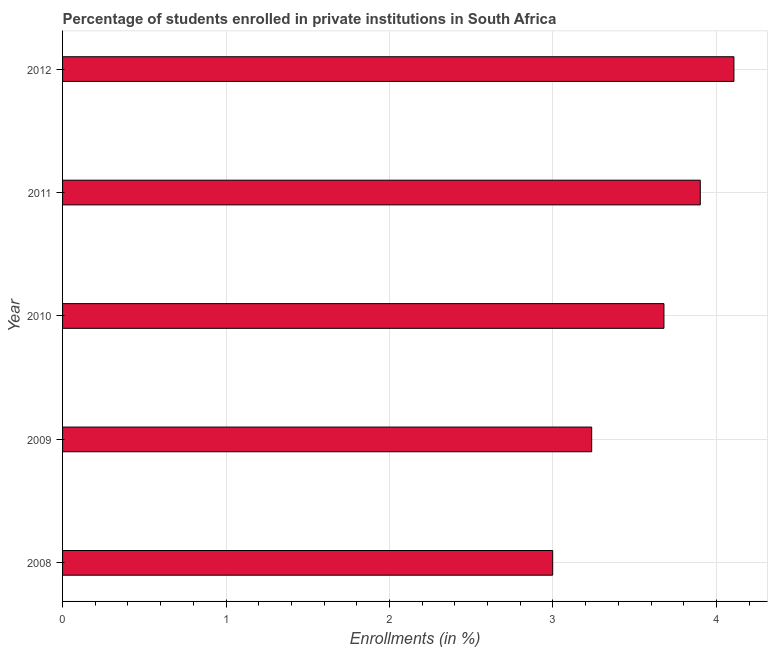Does the graph contain any zero values?
Give a very brief answer. No. Does the graph contain grids?
Your answer should be compact. Yes. What is the title of the graph?
Your response must be concise. Percentage of students enrolled in private institutions in South Africa. What is the label or title of the X-axis?
Make the answer very short. Enrollments (in %). What is the label or title of the Y-axis?
Your answer should be very brief. Year. What is the enrollments in private institutions in 2009?
Offer a very short reply. 3.24. Across all years, what is the maximum enrollments in private institutions?
Offer a very short reply. 4.11. Across all years, what is the minimum enrollments in private institutions?
Provide a succinct answer. 3. What is the sum of the enrollments in private institutions?
Your response must be concise. 17.92. What is the difference between the enrollments in private institutions in 2010 and 2012?
Your response must be concise. -0.43. What is the average enrollments in private institutions per year?
Offer a terse response. 3.58. What is the median enrollments in private institutions?
Your answer should be very brief. 3.68. What is the ratio of the enrollments in private institutions in 2011 to that in 2012?
Ensure brevity in your answer.  0.95. Is the enrollments in private institutions in 2010 less than that in 2011?
Your response must be concise. Yes. Is the difference between the enrollments in private institutions in 2010 and 2012 greater than the difference between any two years?
Ensure brevity in your answer.  No. What is the difference between the highest and the second highest enrollments in private institutions?
Keep it short and to the point. 0.21. Is the sum of the enrollments in private institutions in 2009 and 2010 greater than the maximum enrollments in private institutions across all years?
Offer a very short reply. Yes. What is the difference between the highest and the lowest enrollments in private institutions?
Your answer should be very brief. 1.11. In how many years, is the enrollments in private institutions greater than the average enrollments in private institutions taken over all years?
Offer a very short reply. 3. Are the values on the major ticks of X-axis written in scientific E-notation?
Keep it short and to the point. No. What is the Enrollments (in %) in 2008?
Make the answer very short. 3. What is the Enrollments (in %) of 2009?
Keep it short and to the point. 3.24. What is the Enrollments (in %) in 2010?
Provide a short and direct response. 3.68. What is the Enrollments (in %) in 2011?
Offer a very short reply. 3.9. What is the Enrollments (in %) of 2012?
Offer a terse response. 4.11. What is the difference between the Enrollments (in %) in 2008 and 2009?
Keep it short and to the point. -0.24. What is the difference between the Enrollments (in %) in 2008 and 2010?
Keep it short and to the point. -0.68. What is the difference between the Enrollments (in %) in 2008 and 2011?
Your response must be concise. -0.9. What is the difference between the Enrollments (in %) in 2008 and 2012?
Ensure brevity in your answer.  -1.11. What is the difference between the Enrollments (in %) in 2009 and 2010?
Ensure brevity in your answer.  -0.44. What is the difference between the Enrollments (in %) in 2009 and 2011?
Your answer should be very brief. -0.66. What is the difference between the Enrollments (in %) in 2009 and 2012?
Ensure brevity in your answer.  -0.87. What is the difference between the Enrollments (in %) in 2010 and 2011?
Provide a succinct answer. -0.22. What is the difference between the Enrollments (in %) in 2010 and 2012?
Ensure brevity in your answer.  -0.43. What is the difference between the Enrollments (in %) in 2011 and 2012?
Ensure brevity in your answer.  -0.21. What is the ratio of the Enrollments (in %) in 2008 to that in 2009?
Provide a short and direct response. 0.93. What is the ratio of the Enrollments (in %) in 2008 to that in 2010?
Your answer should be very brief. 0.81. What is the ratio of the Enrollments (in %) in 2008 to that in 2011?
Give a very brief answer. 0.77. What is the ratio of the Enrollments (in %) in 2008 to that in 2012?
Offer a very short reply. 0.73. What is the ratio of the Enrollments (in %) in 2009 to that in 2010?
Your answer should be very brief. 0.88. What is the ratio of the Enrollments (in %) in 2009 to that in 2011?
Offer a terse response. 0.83. What is the ratio of the Enrollments (in %) in 2009 to that in 2012?
Provide a short and direct response. 0.79. What is the ratio of the Enrollments (in %) in 2010 to that in 2011?
Provide a short and direct response. 0.94. What is the ratio of the Enrollments (in %) in 2010 to that in 2012?
Keep it short and to the point. 0.9. What is the ratio of the Enrollments (in %) in 2011 to that in 2012?
Your response must be concise. 0.95. 